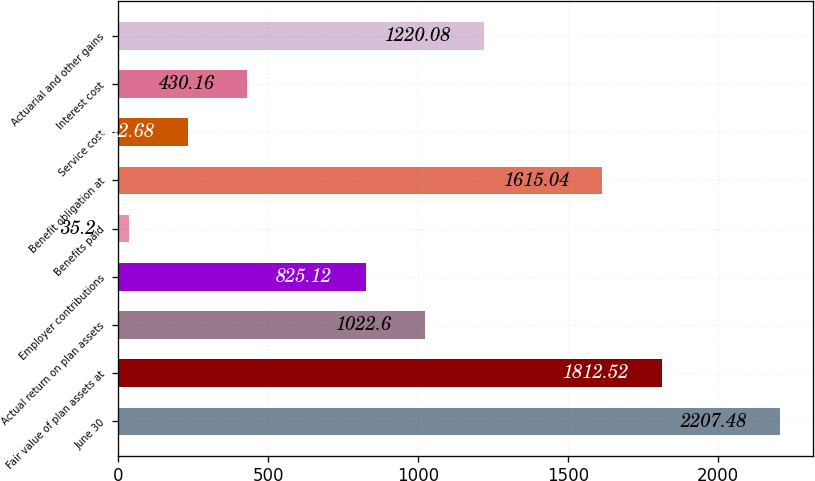Convert chart. <chart><loc_0><loc_0><loc_500><loc_500><bar_chart><fcel>June 30<fcel>Fair value of plan assets at<fcel>Actual return on plan assets<fcel>Employer contributions<fcel>Benefits paid<fcel>Benefit obligation at<fcel>Service cost<fcel>Interest cost<fcel>Actuarial and other gains<nl><fcel>2207.48<fcel>1812.52<fcel>1022.6<fcel>825.12<fcel>35.2<fcel>1615.04<fcel>232.68<fcel>430.16<fcel>1220.08<nl></chart> 